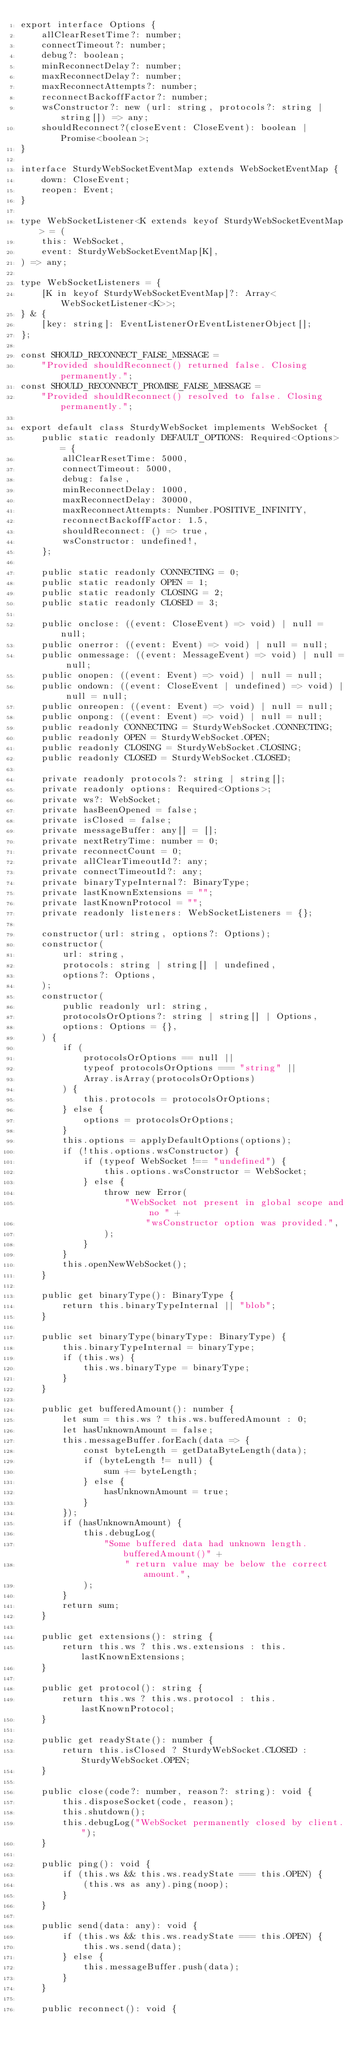Convert code to text. <code><loc_0><loc_0><loc_500><loc_500><_TypeScript_>export interface Options {
    allClearResetTime?: number;
    connectTimeout?: number;
    debug?: boolean;
    minReconnectDelay?: number;
    maxReconnectDelay?: number;
    maxReconnectAttempts?: number;
    reconnectBackoffFactor?: number;
    wsConstructor?: new (url: string, protocols?: string | string[]) => any;
    shouldReconnect?(closeEvent: CloseEvent): boolean | Promise<boolean>;
}

interface SturdyWebSocketEventMap extends WebSocketEventMap {
    down: CloseEvent;
    reopen: Event;
}

type WebSocketListener<K extends keyof SturdyWebSocketEventMap> = (
    this: WebSocket,
    event: SturdyWebSocketEventMap[K],
) => any;

type WebSocketListeners = {
    [K in keyof SturdyWebSocketEventMap]?: Array<WebSocketListener<K>>;
} & {
    [key: string]: EventListenerOrEventListenerObject[];
};

const SHOULD_RECONNECT_FALSE_MESSAGE =
    "Provided shouldReconnect() returned false. Closing permanently.";
const SHOULD_RECONNECT_PROMISE_FALSE_MESSAGE =
    "Provided shouldReconnect() resolved to false. Closing permanently.";

export default class SturdyWebSocket implements WebSocket {
    public static readonly DEFAULT_OPTIONS: Required<Options> = {
        allClearResetTime: 5000,
        connectTimeout: 5000,
        debug: false,
        minReconnectDelay: 1000,
        maxReconnectDelay: 30000,
        maxReconnectAttempts: Number.POSITIVE_INFINITY,
        reconnectBackoffFactor: 1.5,
        shouldReconnect: () => true,
        wsConstructor: undefined!,
    };

    public static readonly CONNECTING = 0;
    public static readonly OPEN = 1;
    public static readonly CLOSING = 2;
    public static readonly CLOSED = 3;

    public onclose: ((event: CloseEvent) => void) | null = null;
    public onerror: ((event: Event) => void) | null = null;
    public onmessage: ((event: MessageEvent) => void) | null = null;
    public onopen: ((event: Event) => void) | null = null;
    public ondown: ((event: CloseEvent | undefined) => void) | null = null;
    public onreopen: ((event: Event) => void) | null = null;
    public onpong: ((event: Event) => void) | null = null;
    public readonly CONNECTING = SturdyWebSocket.CONNECTING;
    public readonly OPEN = SturdyWebSocket.OPEN;
    public readonly CLOSING = SturdyWebSocket.CLOSING;
    public readonly CLOSED = SturdyWebSocket.CLOSED;

    private readonly protocols?: string | string[];
    private readonly options: Required<Options>;
    private ws?: WebSocket;
    private hasBeenOpened = false;
    private isClosed = false;
    private messageBuffer: any[] = [];
    private nextRetryTime: number = 0;
    private reconnectCount = 0;
    private allClearTimeoutId?: any;
    private connectTimeoutId?: any;
    private binaryTypeInternal?: BinaryType;
    private lastKnownExtensions = "";
    private lastKnownProtocol = "";
    private readonly listeners: WebSocketListeners = {};

    constructor(url: string, options?: Options);
    constructor(
        url: string,
        protocols: string | string[] | undefined,
        options?: Options,
    );
    constructor(
        public readonly url: string,
        protocolsOrOptions?: string | string[] | Options,
        options: Options = {},
    ) {
        if (
            protocolsOrOptions == null ||
            typeof protocolsOrOptions === "string" ||
            Array.isArray(protocolsOrOptions)
        ) {
            this.protocols = protocolsOrOptions;
        } else {
            options = protocolsOrOptions;
        }
        this.options = applyDefaultOptions(options);
        if (!this.options.wsConstructor) {
            if (typeof WebSocket !== "undefined") {
                this.options.wsConstructor = WebSocket;
            } else {
                throw new Error(
                    "WebSocket not present in global scope and no " +
                        "wsConstructor option was provided.",
                );
            }
        }
        this.openNewWebSocket();
    }

    public get binaryType(): BinaryType {
        return this.binaryTypeInternal || "blob";
    }

    public set binaryType(binaryType: BinaryType) {
        this.binaryTypeInternal = binaryType;
        if (this.ws) {
            this.ws.binaryType = binaryType;
        }
    }

    public get bufferedAmount(): number {
        let sum = this.ws ? this.ws.bufferedAmount : 0;
        let hasUnknownAmount = false;
        this.messageBuffer.forEach(data => {
            const byteLength = getDataByteLength(data);
            if (byteLength != null) {
                sum += byteLength;
            } else {
                hasUnknownAmount = true;
            }
        });
        if (hasUnknownAmount) {
            this.debugLog(
                "Some buffered data had unknown length. bufferedAmount()" +
                    " return value may be below the correct amount.",
            );
        }
        return sum;
    }

    public get extensions(): string {
        return this.ws ? this.ws.extensions : this.lastKnownExtensions;
    }

    public get protocol(): string {
        return this.ws ? this.ws.protocol : this.lastKnownProtocol;
    }

    public get readyState(): number {
        return this.isClosed ? SturdyWebSocket.CLOSED : SturdyWebSocket.OPEN;
    }

    public close(code?: number, reason?: string): void {
        this.disposeSocket(code, reason);
        this.shutdown();
        this.debugLog("WebSocket permanently closed by client.");
    }

    public ping(): void {
        if (this.ws && this.ws.readyState === this.OPEN) {
            (this.ws as any).ping(noop);
        }
    }

    public send(data: any): void {
        if (this.ws && this.ws.readyState === this.OPEN) {
            this.ws.send(data);
        } else {
            this.messageBuffer.push(data);
        }
    }

    public reconnect(): void {</code> 